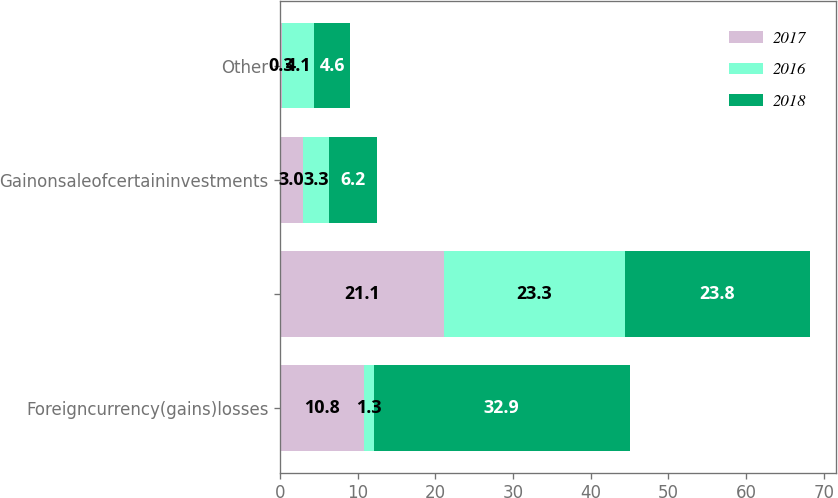Convert chart to OTSL. <chart><loc_0><loc_0><loc_500><loc_500><stacked_bar_chart><ecel><fcel>Foreigncurrency(gains)losses<fcel>Unnamed: 2<fcel>Gainonsaleofcertaininvestments<fcel>Other<nl><fcel>2017<fcel>10.8<fcel>21.1<fcel>3<fcel>0.3<nl><fcel>2016<fcel>1.3<fcel>23.3<fcel>3.3<fcel>4.1<nl><fcel>2018<fcel>32.9<fcel>23.8<fcel>6.2<fcel>4.6<nl></chart> 